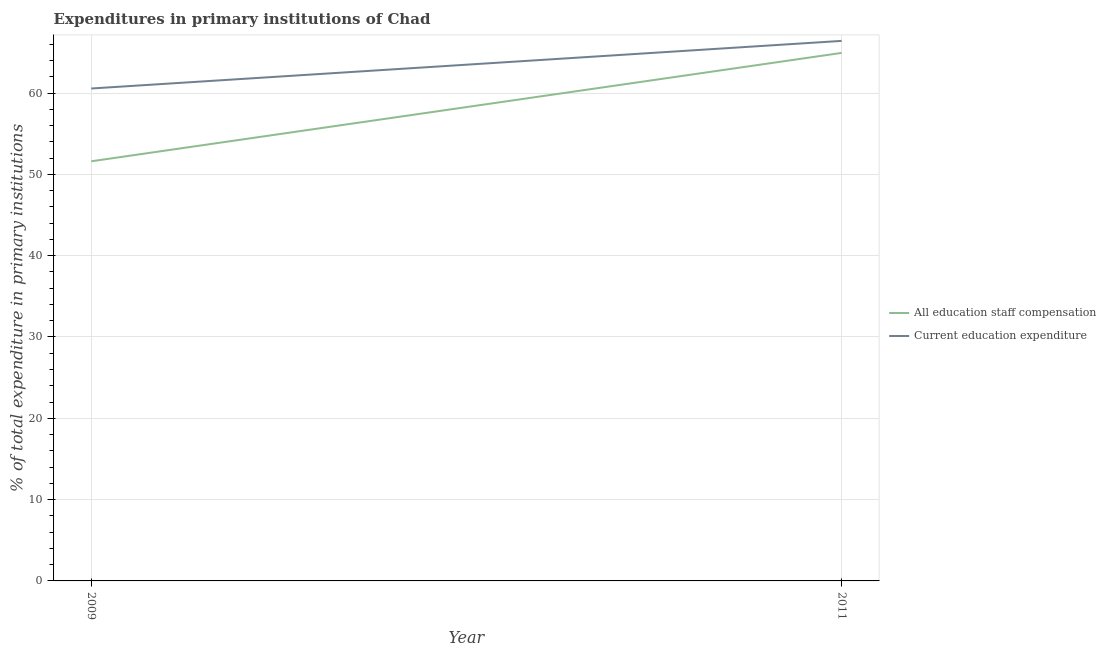Does the line corresponding to expenditure in staff compensation intersect with the line corresponding to expenditure in education?
Give a very brief answer. No. What is the expenditure in education in 2009?
Provide a short and direct response. 60.56. Across all years, what is the maximum expenditure in education?
Give a very brief answer. 66.41. Across all years, what is the minimum expenditure in staff compensation?
Make the answer very short. 51.61. In which year was the expenditure in staff compensation maximum?
Give a very brief answer. 2011. What is the total expenditure in education in the graph?
Ensure brevity in your answer.  126.97. What is the difference between the expenditure in education in 2009 and that in 2011?
Offer a terse response. -5.86. What is the difference between the expenditure in education in 2011 and the expenditure in staff compensation in 2009?
Your answer should be compact. 14.81. What is the average expenditure in staff compensation per year?
Ensure brevity in your answer.  58.27. In the year 2011, what is the difference between the expenditure in education and expenditure in staff compensation?
Your response must be concise. 1.48. In how many years, is the expenditure in education greater than 48 %?
Your answer should be compact. 2. What is the ratio of the expenditure in education in 2009 to that in 2011?
Provide a short and direct response. 0.91. In how many years, is the expenditure in education greater than the average expenditure in education taken over all years?
Keep it short and to the point. 1. Is the expenditure in education strictly greater than the expenditure in staff compensation over the years?
Your answer should be very brief. Yes. Does the graph contain any zero values?
Your answer should be compact. No. Does the graph contain grids?
Your answer should be very brief. Yes. Where does the legend appear in the graph?
Provide a succinct answer. Center right. How are the legend labels stacked?
Make the answer very short. Vertical. What is the title of the graph?
Make the answer very short. Expenditures in primary institutions of Chad. Does "Commercial bank branches" appear as one of the legend labels in the graph?
Provide a succinct answer. No. What is the label or title of the X-axis?
Offer a very short reply. Year. What is the label or title of the Y-axis?
Ensure brevity in your answer.  % of total expenditure in primary institutions. What is the % of total expenditure in primary institutions of All education staff compensation in 2009?
Make the answer very short. 51.61. What is the % of total expenditure in primary institutions in Current education expenditure in 2009?
Make the answer very short. 60.56. What is the % of total expenditure in primary institutions in All education staff compensation in 2011?
Your answer should be very brief. 64.94. What is the % of total expenditure in primary institutions in Current education expenditure in 2011?
Your response must be concise. 66.41. Across all years, what is the maximum % of total expenditure in primary institutions of All education staff compensation?
Offer a very short reply. 64.94. Across all years, what is the maximum % of total expenditure in primary institutions in Current education expenditure?
Provide a succinct answer. 66.41. Across all years, what is the minimum % of total expenditure in primary institutions of All education staff compensation?
Your response must be concise. 51.61. Across all years, what is the minimum % of total expenditure in primary institutions in Current education expenditure?
Offer a terse response. 60.56. What is the total % of total expenditure in primary institutions of All education staff compensation in the graph?
Make the answer very short. 116.54. What is the total % of total expenditure in primary institutions of Current education expenditure in the graph?
Your answer should be compact. 126.97. What is the difference between the % of total expenditure in primary institutions of All education staff compensation in 2009 and that in 2011?
Your answer should be very brief. -13.33. What is the difference between the % of total expenditure in primary institutions in Current education expenditure in 2009 and that in 2011?
Ensure brevity in your answer.  -5.86. What is the difference between the % of total expenditure in primary institutions in All education staff compensation in 2009 and the % of total expenditure in primary institutions in Current education expenditure in 2011?
Give a very brief answer. -14.81. What is the average % of total expenditure in primary institutions of All education staff compensation per year?
Provide a succinct answer. 58.27. What is the average % of total expenditure in primary institutions of Current education expenditure per year?
Offer a terse response. 63.48. In the year 2009, what is the difference between the % of total expenditure in primary institutions of All education staff compensation and % of total expenditure in primary institutions of Current education expenditure?
Give a very brief answer. -8.95. In the year 2011, what is the difference between the % of total expenditure in primary institutions of All education staff compensation and % of total expenditure in primary institutions of Current education expenditure?
Provide a short and direct response. -1.48. What is the ratio of the % of total expenditure in primary institutions in All education staff compensation in 2009 to that in 2011?
Offer a very short reply. 0.79. What is the ratio of the % of total expenditure in primary institutions of Current education expenditure in 2009 to that in 2011?
Provide a succinct answer. 0.91. What is the difference between the highest and the second highest % of total expenditure in primary institutions in All education staff compensation?
Provide a short and direct response. 13.33. What is the difference between the highest and the second highest % of total expenditure in primary institutions of Current education expenditure?
Your response must be concise. 5.86. What is the difference between the highest and the lowest % of total expenditure in primary institutions in All education staff compensation?
Provide a succinct answer. 13.33. What is the difference between the highest and the lowest % of total expenditure in primary institutions of Current education expenditure?
Your response must be concise. 5.86. 